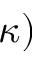<formula> <loc_0><loc_0><loc_500><loc_500>\kappa )</formula> 